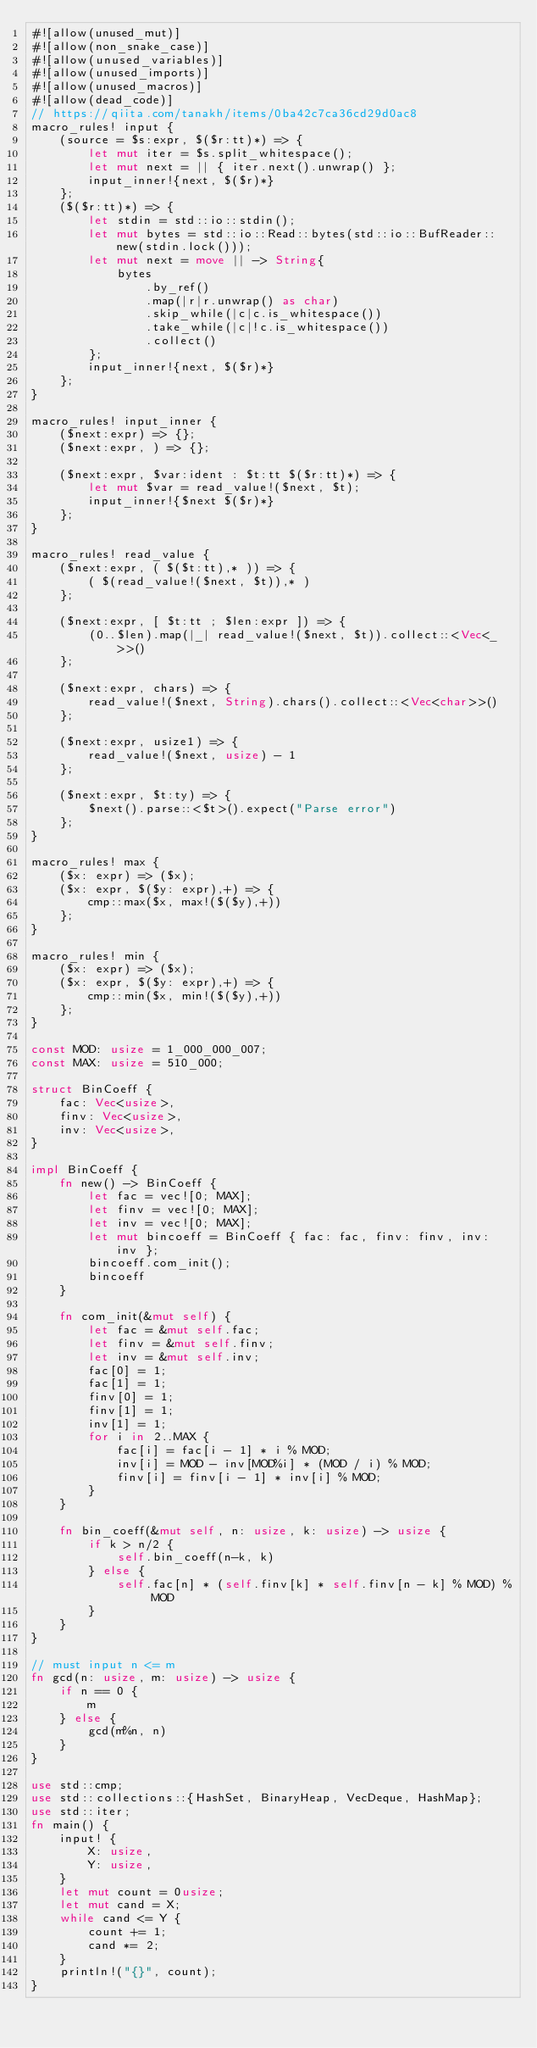Convert code to text. <code><loc_0><loc_0><loc_500><loc_500><_Rust_>#![allow(unused_mut)]
#![allow(non_snake_case)]
#![allow(unused_variables)]
#![allow(unused_imports)]
#![allow(unused_macros)]
#![allow(dead_code)]
// https://qiita.com/tanakh/items/0ba42c7ca36cd29d0ac8
macro_rules! input {
    (source = $s:expr, $($r:tt)*) => {
        let mut iter = $s.split_whitespace();
        let mut next = || { iter.next().unwrap() };
        input_inner!{next, $($r)*}
    };
    ($($r:tt)*) => {
        let stdin = std::io::stdin();
        let mut bytes = std::io::Read::bytes(std::io::BufReader::new(stdin.lock()));
        let mut next = move || -> String{
            bytes
                .by_ref()
                .map(|r|r.unwrap() as char)
                .skip_while(|c|c.is_whitespace())
                .take_while(|c|!c.is_whitespace())
                .collect()
        };
        input_inner!{next, $($r)*}
    };
}

macro_rules! input_inner {
    ($next:expr) => {};
    ($next:expr, ) => {};

    ($next:expr, $var:ident : $t:tt $($r:tt)*) => {
        let mut $var = read_value!($next, $t);
        input_inner!{$next $($r)*}
    };
}

macro_rules! read_value {
    ($next:expr, ( $($t:tt),* )) => {
        ( $(read_value!($next, $t)),* )
    };

    ($next:expr, [ $t:tt ; $len:expr ]) => {
        (0..$len).map(|_| read_value!($next, $t)).collect::<Vec<_>>()
    };

    ($next:expr, chars) => {
        read_value!($next, String).chars().collect::<Vec<char>>()
    };

    ($next:expr, usize1) => {
        read_value!($next, usize) - 1
    };

    ($next:expr, $t:ty) => {
        $next().parse::<$t>().expect("Parse error")
    };
}

macro_rules! max {
    ($x: expr) => ($x);
    ($x: expr, $($y: expr),+) => {
        cmp::max($x, max!($($y),+))
    };
}

macro_rules! min {
    ($x: expr) => ($x);
    ($x: expr, $($y: expr),+) => {
        cmp::min($x, min!($($y),+))
    };
}

const MOD: usize = 1_000_000_007;
const MAX: usize = 510_000;

struct BinCoeff {
    fac: Vec<usize>,
    finv: Vec<usize>,
    inv: Vec<usize>,
}

impl BinCoeff {
    fn new() -> BinCoeff {
        let fac = vec![0; MAX];
        let finv = vec![0; MAX];
        let inv = vec![0; MAX];
        let mut bincoeff = BinCoeff { fac: fac, finv: finv, inv: inv };
        bincoeff.com_init();
        bincoeff
    }

    fn com_init(&mut self) {
        let fac = &mut self.fac;
        let finv = &mut self.finv;
        let inv = &mut self.inv;
        fac[0] = 1;
        fac[1] = 1;
        finv[0] = 1;
        finv[1] = 1;
        inv[1] = 1;
        for i in 2..MAX {
            fac[i] = fac[i - 1] * i % MOD;
            inv[i] = MOD - inv[MOD%i] * (MOD / i) % MOD;
            finv[i] = finv[i - 1] * inv[i] % MOD;
        }
    }

    fn bin_coeff(&mut self, n: usize, k: usize) -> usize {
        if k > n/2 {
            self.bin_coeff(n-k, k)
        } else {
            self.fac[n] * (self.finv[k] * self.finv[n - k] % MOD) % MOD
        }
    }
}

// must input n <= m
fn gcd(n: usize, m: usize) -> usize {
    if n == 0 {
        m
    } else {
        gcd(m%n, n)
    }
}

use std::cmp;
use std::collections::{HashSet, BinaryHeap, VecDeque, HashMap};
use std::iter;
fn main() {
    input! {
        X: usize,
        Y: usize,
    }
    let mut count = 0usize;
    let mut cand = X;
    while cand <= Y {
        count += 1;
        cand *= 2;
    }
    println!("{}", count);
}
</code> 